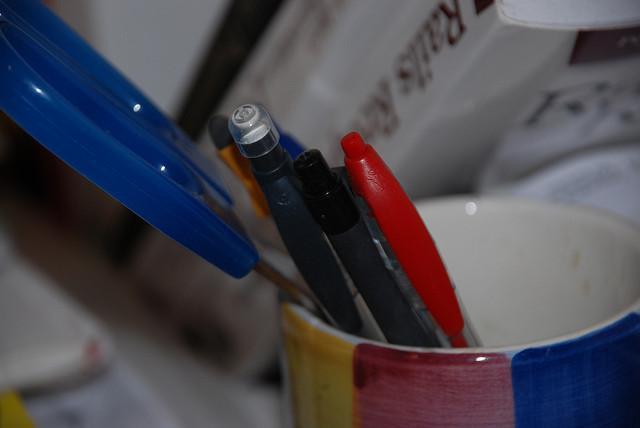How many umbrellas are there?
Give a very brief answer. 0. 